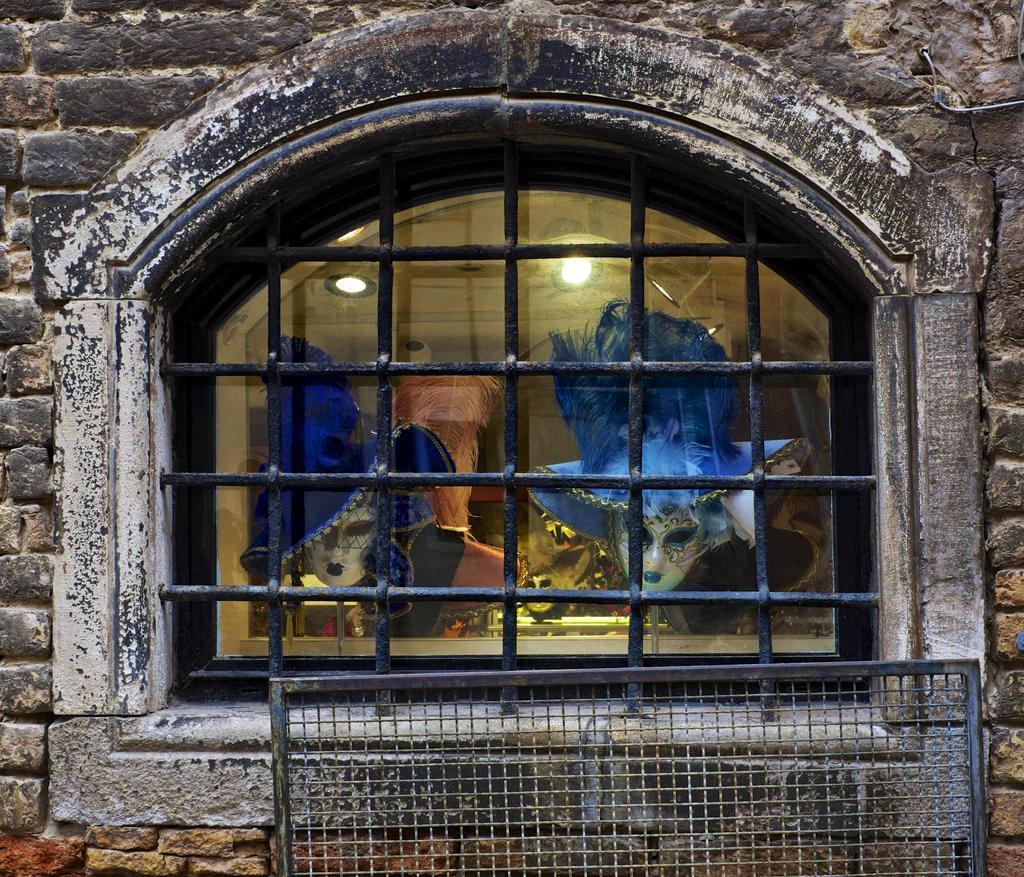Could you give a brief overview of what you see in this image? In this image there is a wall and we can see a window. There is a mesh. We can see masks and lights through the window glass. 